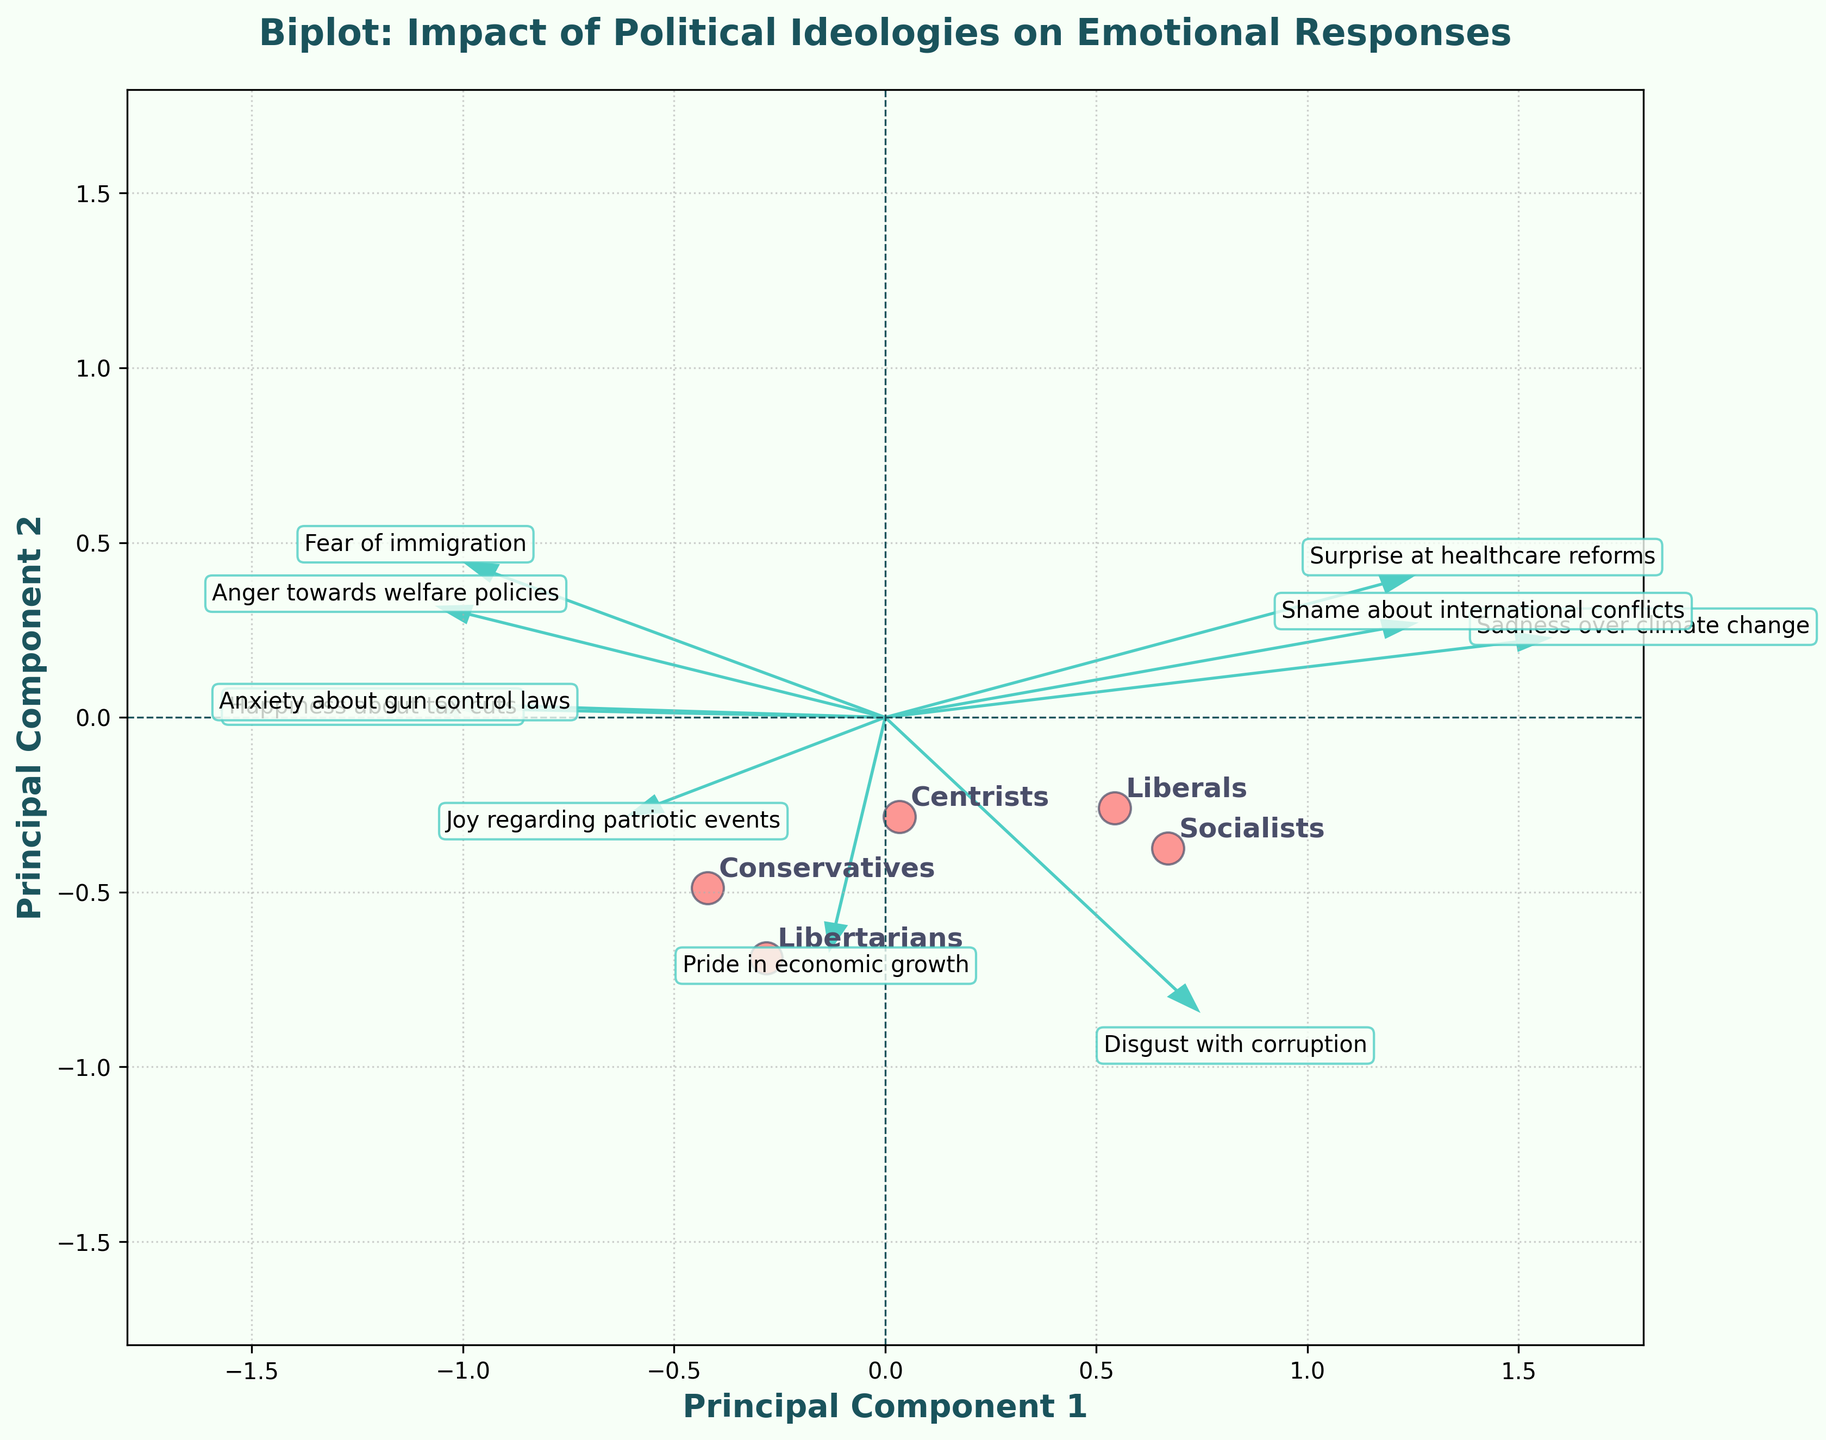What is the title of the plot? The title is displayed at the top of the plot and reads "Biplot: Impact of Political Ideologies on Emotional Responses".
Answer: Biplot: Impact of Political Ideologies on Emotional Responses How many political ideologies are represented in the plot? By looking at the distinct annotations and data points, we can see that there are five political ideologies represented: Conservatives, Liberals, Centrists, Libertarians, and Socialists.
Answer: Five Which political ideology is positioned closest to the vertical axis? The ideology positioned closest to the vertical axis is the one with the smallest X-value. By observing the scatter plot, Libertarians appear to be closest to the vertical axis.
Answer: Libertarians Between "Conservatives" and "Liberals", which ideology shows a higher influence from Principal Component 1 (PC1)? PC1 is represented on the x-axis. Comparing the horizontal positions of "Conservatives" and "Liberals", Conservatives are further to the right, indicating a higher influence from PC1.
Answer: Conservatives Which emotion variable lies closest to the origin? The origin is located at (0,0). Comparing the distances from the origin for each arrow representing variables, "Surprise at healthcare reforms" is the closest to the origin.
Answer: Surprise at healthcare reforms What can you infer about "Anger towards welfare policies" in relation to "Conservatives" and "Liberals"? The arrows represent variables, and we can gauge relationships by observing the angles and directions relative to the points for ideologies. "Anger towards welfare policies" points towards the direction of Conservatives and away from Liberals, indicating higher anger in Conservatives and lower in Liberals.
Answer: Conservatives show higher anger; Liberals show lower How are "Socialists" and "Libertarians" positioned relative to each other along Principal Component 2 (PC2)? PC2 is represented on the y-axis. Comparing the vertical positions of "Socialists" and "Libertarians", Socialists are positioned higher than Libertarians along PC2.
Answer: Socialists are higher Which variable shows a positive reaction (e.g., happiness) from both "Libertarians" and "Conservatives"? The arrows of the variables represent their relationships. The "Happiness about tax cuts" arrow points towards both the "Libertarians" and "Conservatives", indicating a positive reaction from both groups.
Answer: Happiness about tax cuts What is the approximate length of the arrow representing "Disgust with corruption"? The arrows' lengths represent the significance of the variables. "Disgust with corruption" has a noticeable arrow length, approximately less than halfway across the plot area, suggesting a high but not extreme impact.
Answer: Significant but not extreme Which two political ideologies are positioned most similarly according to the biplot? Ideologies positioned closest to each other in both PC1 and PC2 dimensions are more similar. Observing the plot, "Centrists" and "Libertarians" are closest to each other.
Answer: Centrists and Libertarians 